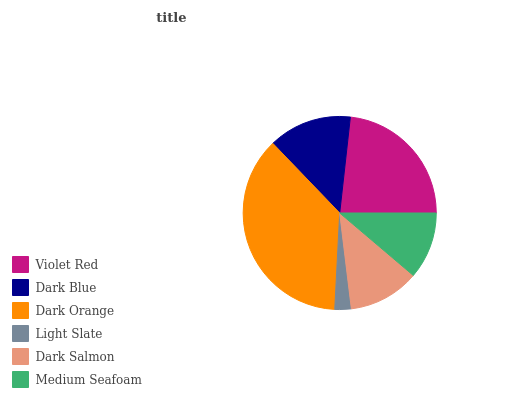Is Light Slate the minimum?
Answer yes or no. Yes. Is Dark Orange the maximum?
Answer yes or no. Yes. Is Dark Blue the minimum?
Answer yes or no. No. Is Dark Blue the maximum?
Answer yes or no. No. Is Violet Red greater than Dark Blue?
Answer yes or no. Yes. Is Dark Blue less than Violet Red?
Answer yes or no. Yes. Is Dark Blue greater than Violet Red?
Answer yes or no. No. Is Violet Red less than Dark Blue?
Answer yes or no. No. Is Dark Blue the high median?
Answer yes or no. Yes. Is Dark Salmon the low median?
Answer yes or no. Yes. Is Violet Red the high median?
Answer yes or no. No. Is Dark Blue the low median?
Answer yes or no. No. 